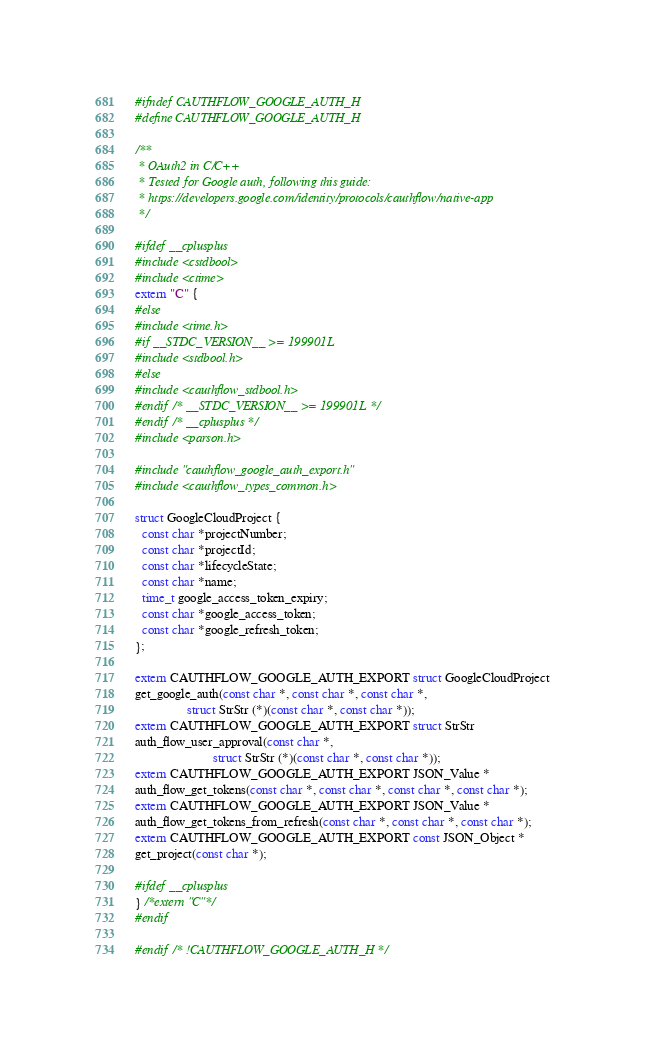<code> <loc_0><loc_0><loc_500><loc_500><_C_>#ifndef CAUTHFLOW_GOOGLE_AUTH_H
#define CAUTHFLOW_GOOGLE_AUTH_H

/**
 * OAuth2 in C/C++
 * Tested for Google auth, following this guide:
 * https://developers.google.com/identity/protocols/cauthflow/native-app
 */

#ifdef __cplusplus
#include <cstdbool>
#include <ctime>
extern "C" {
#else
#include <time.h>
#if __STDC_VERSION__ >= 199901L
#include <stdbool.h>
#else
#include <cauthflow_stdbool.h>
#endif /* __STDC_VERSION__ >= 199901L */
#endif /* __cplusplus */
#include <parson.h>

#include "cauthflow_google_auth_export.h"
#include <cauthflow_types_common.h>

struct GoogleCloudProject {
  const char *projectNumber;
  const char *projectId;
  const char *lifecycleState;
  const char *name;
  time_t google_access_token_expiry;
  const char *google_access_token;
  const char *google_refresh_token;
};

extern CAUTHFLOW_GOOGLE_AUTH_EXPORT struct GoogleCloudProject
get_google_auth(const char *, const char *, const char *,
                struct StrStr (*)(const char *, const char *));
extern CAUTHFLOW_GOOGLE_AUTH_EXPORT struct StrStr
auth_flow_user_approval(const char *,
                        struct StrStr (*)(const char *, const char *));
extern CAUTHFLOW_GOOGLE_AUTH_EXPORT JSON_Value *
auth_flow_get_tokens(const char *, const char *, const char *, const char *);
extern CAUTHFLOW_GOOGLE_AUTH_EXPORT JSON_Value *
auth_flow_get_tokens_from_refresh(const char *, const char *, const char *);
extern CAUTHFLOW_GOOGLE_AUTH_EXPORT const JSON_Object *
get_project(const char *);

#ifdef __cplusplus
} /*extern "C"*/
#endif

#endif /* !CAUTHFLOW_GOOGLE_AUTH_H */
</code> 